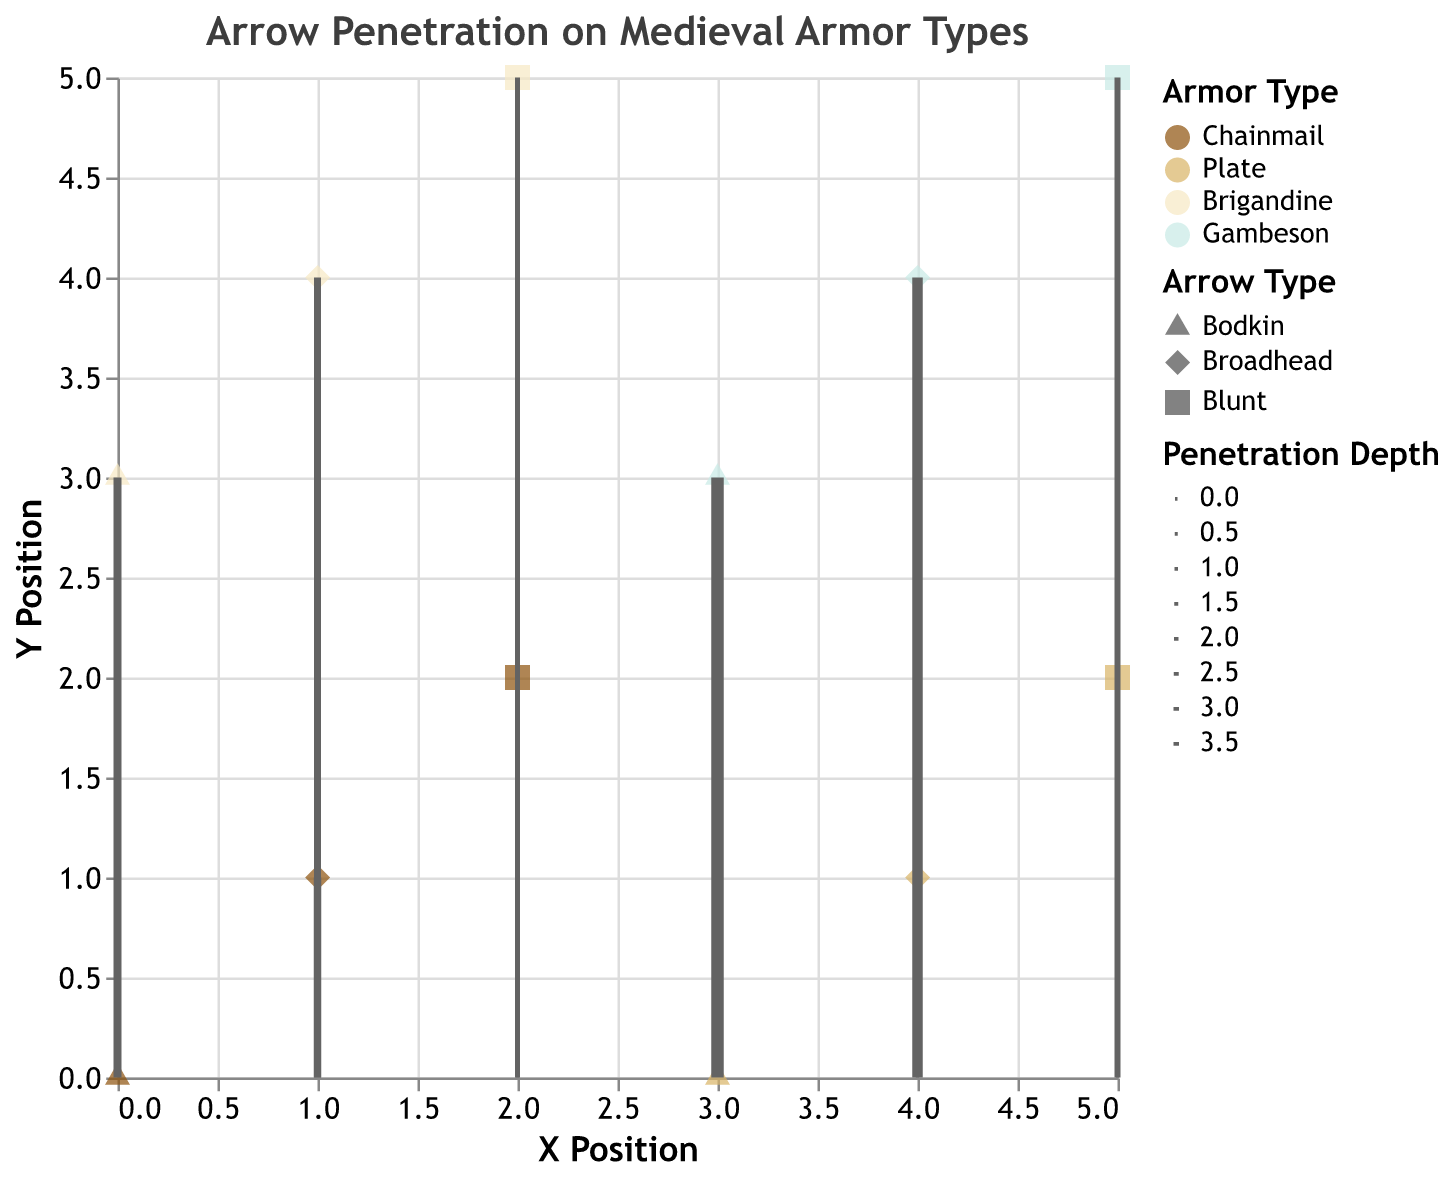What is the title of the figure? The title is the primary text displayed at the top of the figure. It provides a brief explanation of what the figure represents. In this case, the title is "Arrow Penetration on Medieval Armor Types".
Answer: Arrow Penetration on Medieval Armor Types How many arrows penetrated the Plate armor? Count the number of entries where "armor_type" is "Plate". There are three data points for Plate armor: one each for Bodkin, Broadhead, and Blunt.
Answer: 3 Which armor type has the greatest penetration depth for Bodkin arrows? Look at the data points for Bodkin arrows and compare the penetration depths across different armor types. Gambeson with a penetration depth of 3.5 has the greatest penetration depth.
Answer: Gambeson Which arrow type shows the least penetration depth in the Gambeson armor? Look at the data points where "armor_type" is "Gambeson" and compare the penetration depths for Bodkin, Broadhead, and Blunt arrows. The Blunt arrow has the least penetration depth with 1.2.
Answer: Blunt What is the range of penetration depths for Chainmail armor? Identify the penetration depths for Chainmail armor (2.5, 1.8, 0.5), then find the difference between the maximum and minimum values: 2.5 - 0.5 = 2.0.
Answer: 2.0 Which arrow type has the highest average penetration depth across all armor types? Calculate the average penetration depth for each arrow type by summing the penetration depths and dividing by the number of data points for each arrow type: 
Bodkin: (2.5 + 1.2 + 2.0 + 3.5) / 4 = 2.3
Broadhead: (1.8 + 0.3 + 1.5 + 2.8) / 4 = 1.6
Blunt: (0.5 + 0.1 + 0.8 + 1.2) / 4 = 0.65
The Bodkin arrow type has the highest average penetration depth of 2.3.
Answer: Bodkin Compare the angles of penetration for Chainmail and Brigandine when hit by Broadhead arrows. Which armor has a higher angle? Look at the "angle" values for Chainmail and Brigandine when using Broadhead arrows:
Chainmail: 30
Brigandine: 25
Chainmail has a higher angle of 30 degrees compared to Brigandine's 25 degrees.
Answer: Chainmail Which armor type experienced the shallowest penetration depth overall? Identify the smallest penetration depth value in the dataset. The shallowest penetration depth is 0.1 for Plate armor.
Answer: Plate Which arrow type has the most consistent penetration depth across all armor types in terms of variability? Calculate the range of penetration depths for each arrow type:
Bodkin: 3.5 - 1.2 = 2.3
Broadhead: 2.8 - 0.3 = 2.5
Blunt: 1.2 - 0.1 = 1.1
The Blunt arrow has the smallest range of 1.1, indicating the most consistent penetration depth.
Answer: Blunt 